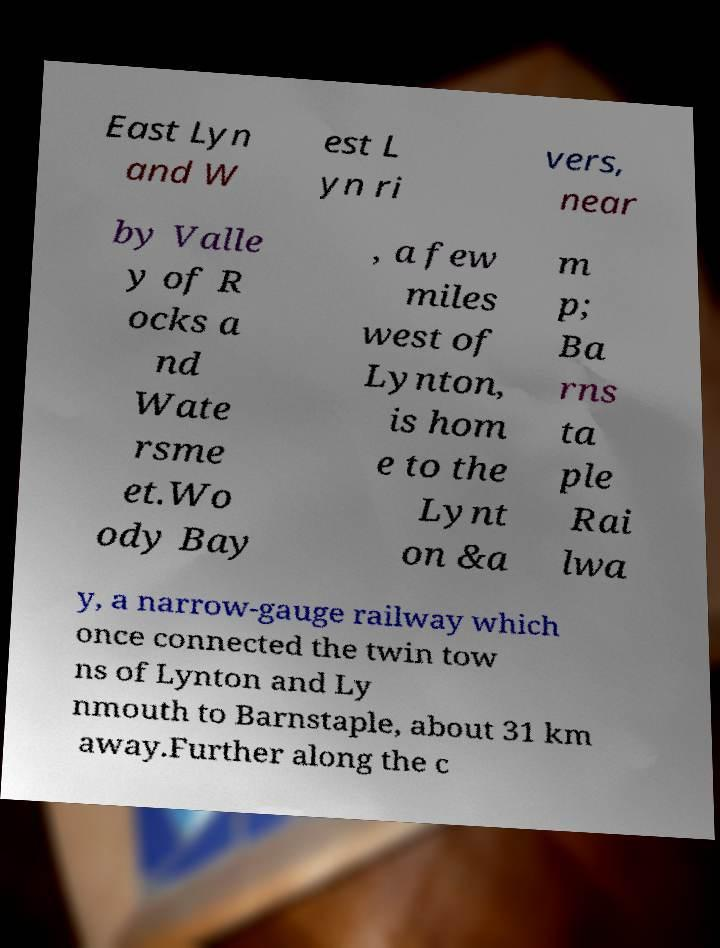There's text embedded in this image that I need extracted. Can you transcribe it verbatim? East Lyn and W est L yn ri vers, near by Valle y of R ocks a nd Wate rsme et.Wo ody Bay , a few miles west of Lynton, is hom e to the Lynt on &a m p; Ba rns ta ple Rai lwa y, a narrow-gauge railway which once connected the twin tow ns of Lynton and Ly nmouth to Barnstaple, about 31 km away.Further along the c 